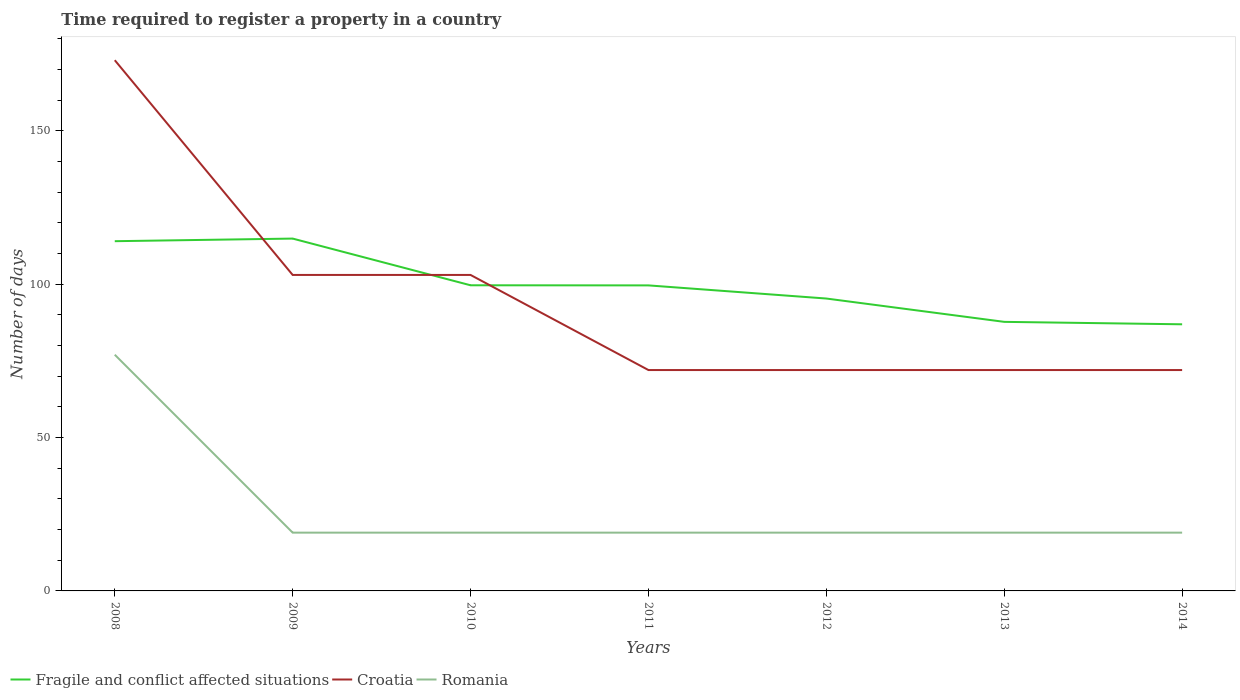How many different coloured lines are there?
Provide a short and direct response. 3. Does the line corresponding to Croatia intersect with the line corresponding to Fragile and conflict affected situations?
Your answer should be very brief. Yes. Across all years, what is the maximum number of days required to register a property in Fragile and conflict affected situations?
Provide a short and direct response. 86.91. In which year was the number of days required to register a property in Fragile and conflict affected situations maximum?
Provide a succinct answer. 2014. What is the total number of days required to register a property in Croatia in the graph?
Keep it short and to the point. 101. What is the difference between the highest and the second highest number of days required to register a property in Fragile and conflict affected situations?
Ensure brevity in your answer.  27.94. What is the difference between the highest and the lowest number of days required to register a property in Fragile and conflict affected situations?
Your answer should be very brief. 2. What is the difference between two consecutive major ticks on the Y-axis?
Your response must be concise. 50. Are the values on the major ticks of Y-axis written in scientific E-notation?
Keep it short and to the point. No. Where does the legend appear in the graph?
Provide a succinct answer. Bottom left. What is the title of the graph?
Keep it short and to the point. Time required to register a property in a country. Does "Iceland" appear as one of the legend labels in the graph?
Provide a short and direct response. No. What is the label or title of the X-axis?
Your answer should be compact. Years. What is the label or title of the Y-axis?
Provide a succinct answer. Number of days. What is the Number of days in Fragile and conflict affected situations in 2008?
Offer a terse response. 114. What is the Number of days in Croatia in 2008?
Ensure brevity in your answer.  173. What is the Number of days of Fragile and conflict affected situations in 2009?
Offer a very short reply. 114.85. What is the Number of days of Croatia in 2009?
Keep it short and to the point. 103. What is the Number of days in Fragile and conflict affected situations in 2010?
Keep it short and to the point. 99.63. What is the Number of days of Croatia in 2010?
Your answer should be very brief. 103. What is the Number of days of Romania in 2010?
Your answer should be compact. 19. What is the Number of days in Fragile and conflict affected situations in 2011?
Offer a terse response. 99.59. What is the Number of days in Romania in 2011?
Give a very brief answer. 19. What is the Number of days in Fragile and conflict affected situations in 2012?
Keep it short and to the point. 95.31. What is the Number of days of Romania in 2012?
Keep it short and to the point. 19. What is the Number of days of Fragile and conflict affected situations in 2013?
Offer a very short reply. 87.71. What is the Number of days in Fragile and conflict affected situations in 2014?
Give a very brief answer. 86.91. Across all years, what is the maximum Number of days in Fragile and conflict affected situations?
Your answer should be very brief. 114.85. Across all years, what is the maximum Number of days in Croatia?
Provide a succinct answer. 173. Across all years, what is the maximum Number of days of Romania?
Provide a short and direct response. 77. Across all years, what is the minimum Number of days of Fragile and conflict affected situations?
Offer a very short reply. 86.91. Across all years, what is the minimum Number of days in Croatia?
Make the answer very short. 72. What is the total Number of days in Fragile and conflict affected situations in the graph?
Provide a succinct answer. 698.01. What is the total Number of days in Croatia in the graph?
Your response must be concise. 667. What is the total Number of days in Romania in the graph?
Make the answer very short. 191. What is the difference between the Number of days of Fragile and conflict affected situations in 2008 and that in 2009?
Ensure brevity in your answer.  -0.85. What is the difference between the Number of days in Croatia in 2008 and that in 2009?
Your answer should be compact. 70. What is the difference between the Number of days in Romania in 2008 and that in 2009?
Your answer should be compact. 58. What is the difference between the Number of days of Fragile and conflict affected situations in 2008 and that in 2010?
Your answer should be very brief. 14.37. What is the difference between the Number of days of Fragile and conflict affected situations in 2008 and that in 2011?
Your answer should be compact. 14.41. What is the difference between the Number of days of Croatia in 2008 and that in 2011?
Offer a terse response. 101. What is the difference between the Number of days of Romania in 2008 and that in 2011?
Provide a succinct answer. 58. What is the difference between the Number of days of Fragile and conflict affected situations in 2008 and that in 2012?
Your response must be concise. 18.69. What is the difference between the Number of days of Croatia in 2008 and that in 2012?
Offer a very short reply. 101. What is the difference between the Number of days in Fragile and conflict affected situations in 2008 and that in 2013?
Make the answer very short. 26.29. What is the difference between the Number of days of Croatia in 2008 and that in 2013?
Your response must be concise. 101. What is the difference between the Number of days of Romania in 2008 and that in 2013?
Your answer should be compact. 58. What is the difference between the Number of days in Fragile and conflict affected situations in 2008 and that in 2014?
Keep it short and to the point. 27.09. What is the difference between the Number of days in Croatia in 2008 and that in 2014?
Make the answer very short. 101. What is the difference between the Number of days of Romania in 2008 and that in 2014?
Offer a terse response. 58. What is the difference between the Number of days of Fragile and conflict affected situations in 2009 and that in 2010?
Make the answer very short. 15.22. What is the difference between the Number of days of Croatia in 2009 and that in 2010?
Give a very brief answer. 0. What is the difference between the Number of days in Romania in 2009 and that in 2010?
Your response must be concise. 0. What is the difference between the Number of days of Fragile and conflict affected situations in 2009 and that in 2011?
Give a very brief answer. 15.26. What is the difference between the Number of days in Fragile and conflict affected situations in 2009 and that in 2012?
Offer a terse response. 19.54. What is the difference between the Number of days in Croatia in 2009 and that in 2012?
Give a very brief answer. 31. What is the difference between the Number of days of Romania in 2009 and that in 2012?
Your answer should be compact. 0. What is the difference between the Number of days of Fragile and conflict affected situations in 2009 and that in 2013?
Make the answer very short. 27.14. What is the difference between the Number of days of Croatia in 2009 and that in 2013?
Ensure brevity in your answer.  31. What is the difference between the Number of days of Romania in 2009 and that in 2013?
Offer a very short reply. 0. What is the difference between the Number of days in Fragile and conflict affected situations in 2009 and that in 2014?
Your response must be concise. 27.94. What is the difference between the Number of days of Fragile and conflict affected situations in 2010 and that in 2011?
Provide a short and direct response. 0.04. What is the difference between the Number of days in Croatia in 2010 and that in 2011?
Keep it short and to the point. 31. What is the difference between the Number of days in Fragile and conflict affected situations in 2010 and that in 2012?
Your response must be concise. 4.32. What is the difference between the Number of days of Croatia in 2010 and that in 2012?
Provide a succinct answer. 31. What is the difference between the Number of days of Fragile and conflict affected situations in 2010 and that in 2013?
Ensure brevity in your answer.  11.92. What is the difference between the Number of days of Fragile and conflict affected situations in 2010 and that in 2014?
Offer a very short reply. 12.72. What is the difference between the Number of days in Fragile and conflict affected situations in 2011 and that in 2012?
Offer a terse response. 4.28. What is the difference between the Number of days in Fragile and conflict affected situations in 2011 and that in 2013?
Give a very brief answer. 11.89. What is the difference between the Number of days in Croatia in 2011 and that in 2013?
Ensure brevity in your answer.  0. What is the difference between the Number of days in Fragile and conflict affected situations in 2011 and that in 2014?
Provide a succinct answer. 12.68. What is the difference between the Number of days of Croatia in 2011 and that in 2014?
Provide a short and direct response. 0. What is the difference between the Number of days in Romania in 2011 and that in 2014?
Offer a very short reply. 0. What is the difference between the Number of days in Fragile and conflict affected situations in 2012 and that in 2013?
Ensure brevity in your answer.  7.6. What is the difference between the Number of days in Romania in 2012 and that in 2013?
Give a very brief answer. 0. What is the difference between the Number of days of Fragile and conflict affected situations in 2012 and that in 2014?
Give a very brief answer. 8.4. What is the difference between the Number of days of Croatia in 2012 and that in 2014?
Your answer should be very brief. 0. What is the difference between the Number of days in Romania in 2012 and that in 2014?
Make the answer very short. 0. What is the difference between the Number of days in Fragile and conflict affected situations in 2013 and that in 2014?
Offer a terse response. 0.79. What is the difference between the Number of days in Fragile and conflict affected situations in 2008 and the Number of days in Croatia in 2009?
Offer a terse response. 11. What is the difference between the Number of days in Croatia in 2008 and the Number of days in Romania in 2009?
Offer a terse response. 154. What is the difference between the Number of days of Fragile and conflict affected situations in 2008 and the Number of days of Croatia in 2010?
Offer a very short reply. 11. What is the difference between the Number of days of Fragile and conflict affected situations in 2008 and the Number of days of Romania in 2010?
Make the answer very short. 95. What is the difference between the Number of days of Croatia in 2008 and the Number of days of Romania in 2010?
Make the answer very short. 154. What is the difference between the Number of days of Fragile and conflict affected situations in 2008 and the Number of days of Romania in 2011?
Your answer should be very brief. 95. What is the difference between the Number of days in Croatia in 2008 and the Number of days in Romania in 2011?
Offer a very short reply. 154. What is the difference between the Number of days of Fragile and conflict affected situations in 2008 and the Number of days of Croatia in 2012?
Keep it short and to the point. 42. What is the difference between the Number of days in Fragile and conflict affected situations in 2008 and the Number of days in Romania in 2012?
Give a very brief answer. 95. What is the difference between the Number of days in Croatia in 2008 and the Number of days in Romania in 2012?
Give a very brief answer. 154. What is the difference between the Number of days of Fragile and conflict affected situations in 2008 and the Number of days of Croatia in 2013?
Make the answer very short. 42. What is the difference between the Number of days of Fragile and conflict affected situations in 2008 and the Number of days of Romania in 2013?
Offer a very short reply. 95. What is the difference between the Number of days of Croatia in 2008 and the Number of days of Romania in 2013?
Ensure brevity in your answer.  154. What is the difference between the Number of days of Fragile and conflict affected situations in 2008 and the Number of days of Croatia in 2014?
Your response must be concise. 42. What is the difference between the Number of days of Fragile and conflict affected situations in 2008 and the Number of days of Romania in 2014?
Give a very brief answer. 95. What is the difference between the Number of days of Croatia in 2008 and the Number of days of Romania in 2014?
Provide a short and direct response. 154. What is the difference between the Number of days of Fragile and conflict affected situations in 2009 and the Number of days of Croatia in 2010?
Give a very brief answer. 11.85. What is the difference between the Number of days of Fragile and conflict affected situations in 2009 and the Number of days of Romania in 2010?
Keep it short and to the point. 95.85. What is the difference between the Number of days in Croatia in 2009 and the Number of days in Romania in 2010?
Provide a succinct answer. 84. What is the difference between the Number of days in Fragile and conflict affected situations in 2009 and the Number of days in Croatia in 2011?
Ensure brevity in your answer.  42.85. What is the difference between the Number of days of Fragile and conflict affected situations in 2009 and the Number of days of Romania in 2011?
Your response must be concise. 95.85. What is the difference between the Number of days in Fragile and conflict affected situations in 2009 and the Number of days in Croatia in 2012?
Your answer should be very brief. 42.85. What is the difference between the Number of days of Fragile and conflict affected situations in 2009 and the Number of days of Romania in 2012?
Your answer should be compact. 95.85. What is the difference between the Number of days in Croatia in 2009 and the Number of days in Romania in 2012?
Provide a succinct answer. 84. What is the difference between the Number of days in Fragile and conflict affected situations in 2009 and the Number of days in Croatia in 2013?
Provide a succinct answer. 42.85. What is the difference between the Number of days of Fragile and conflict affected situations in 2009 and the Number of days of Romania in 2013?
Your answer should be compact. 95.85. What is the difference between the Number of days of Croatia in 2009 and the Number of days of Romania in 2013?
Your answer should be compact. 84. What is the difference between the Number of days of Fragile and conflict affected situations in 2009 and the Number of days of Croatia in 2014?
Give a very brief answer. 42.85. What is the difference between the Number of days in Fragile and conflict affected situations in 2009 and the Number of days in Romania in 2014?
Provide a succinct answer. 95.85. What is the difference between the Number of days in Croatia in 2009 and the Number of days in Romania in 2014?
Offer a very short reply. 84. What is the difference between the Number of days in Fragile and conflict affected situations in 2010 and the Number of days in Croatia in 2011?
Ensure brevity in your answer.  27.63. What is the difference between the Number of days of Fragile and conflict affected situations in 2010 and the Number of days of Romania in 2011?
Provide a succinct answer. 80.63. What is the difference between the Number of days in Croatia in 2010 and the Number of days in Romania in 2011?
Your response must be concise. 84. What is the difference between the Number of days in Fragile and conflict affected situations in 2010 and the Number of days in Croatia in 2012?
Provide a succinct answer. 27.63. What is the difference between the Number of days in Fragile and conflict affected situations in 2010 and the Number of days in Romania in 2012?
Your response must be concise. 80.63. What is the difference between the Number of days in Fragile and conflict affected situations in 2010 and the Number of days in Croatia in 2013?
Offer a terse response. 27.63. What is the difference between the Number of days of Fragile and conflict affected situations in 2010 and the Number of days of Romania in 2013?
Offer a terse response. 80.63. What is the difference between the Number of days of Croatia in 2010 and the Number of days of Romania in 2013?
Give a very brief answer. 84. What is the difference between the Number of days in Fragile and conflict affected situations in 2010 and the Number of days in Croatia in 2014?
Keep it short and to the point. 27.63. What is the difference between the Number of days of Fragile and conflict affected situations in 2010 and the Number of days of Romania in 2014?
Your answer should be very brief. 80.63. What is the difference between the Number of days in Croatia in 2010 and the Number of days in Romania in 2014?
Provide a short and direct response. 84. What is the difference between the Number of days of Fragile and conflict affected situations in 2011 and the Number of days of Croatia in 2012?
Make the answer very short. 27.59. What is the difference between the Number of days of Fragile and conflict affected situations in 2011 and the Number of days of Romania in 2012?
Make the answer very short. 80.59. What is the difference between the Number of days of Fragile and conflict affected situations in 2011 and the Number of days of Croatia in 2013?
Keep it short and to the point. 27.59. What is the difference between the Number of days of Fragile and conflict affected situations in 2011 and the Number of days of Romania in 2013?
Give a very brief answer. 80.59. What is the difference between the Number of days in Fragile and conflict affected situations in 2011 and the Number of days in Croatia in 2014?
Provide a short and direct response. 27.59. What is the difference between the Number of days of Fragile and conflict affected situations in 2011 and the Number of days of Romania in 2014?
Offer a terse response. 80.59. What is the difference between the Number of days of Croatia in 2011 and the Number of days of Romania in 2014?
Your response must be concise. 53. What is the difference between the Number of days in Fragile and conflict affected situations in 2012 and the Number of days in Croatia in 2013?
Keep it short and to the point. 23.31. What is the difference between the Number of days of Fragile and conflict affected situations in 2012 and the Number of days of Romania in 2013?
Offer a very short reply. 76.31. What is the difference between the Number of days of Fragile and conflict affected situations in 2012 and the Number of days of Croatia in 2014?
Keep it short and to the point. 23.31. What is the difference between the Number of days in Fragile and conflict affected situations in 2012 and the Number of days in Romania in 2014?
Give a very brief answer. 76.31. What is the difference between the Number of days of Fragile and conflict affected situations in 2013 and the Number of days of Croatia in 2014?
Provide a short and direct response. 15.71. What is the difference between the Number of days of Fragile and conflict affected situations in 2013 and the Number of days of Romania in 2014?
Give a very brief answer. 68.71. What is the average Number of days of Fragile and conflict affected situations per year?
Provide a succinct answer. 99.72. What is the average Number of days of Croatia per year?
Provide a short and direct response. 95.29. What is the average Number of days in Romania per year?
Offer a terse response. 27.29. In the year 2008, what is the difference between the Number of days in Fragile and conflict affected situations and Number of days in Croatia?
Give a very brief answer. -59. In the year 2008, what is the difference between the Number of days in Croatia and Number of days in Romania?
Your answer should be compact. 96. In the year 2009, what is the difference between the Number of days in Fragile and conflict affected situations and Number of days in Croatia?
Keep it short and to the point. 11.85. In the year 2009, what is the difference between the Number of days in Fragile and conflict affected situations and Number of days in Romania?
Provide a short and direct response. 95.85. In the year 2010, what is the difference between the Number of days of Fragile and conflict affected situations and Number of days of Croatia?
Keep it short and to the point. -3.37. In the year 2010, what is the difference between the Number of days of Fragile and conflict affected situations and Number of days of Romania?
Give a very brief answer. 80.63. In the year 2010, what is the difference between the Number of days in Croatia and Number of days in Romania?
Provide a succinct answer. 84. In the year 2011, what is the difference between the Number of days in Fragile and conflict affected situations and Number of days in Croatia?
Provide a short and direct response. 27.59. In the year 2011, what is the difference between the Number of days in Fragile and conflict affected situations and Number of days in Romania?
Make the answer very short. 80.59. In the year 2012, what is the difference between the Number of days of Fragile and conflict affected situations and Number of days of Croatia?
Offer a terse response. 23.31. In the year 2012, what is the difference between the Number of days of Fragile and conflict affected situations and Number of days of Romania?
Your response must be concise. 76.31. In the year 2012, what is the difference between the Number of days of Croatia and Number of days of Romania?
Offer a very short reply. 53. In the year 2013, what is the difference between the Number of days of Fragile and conflict affected situations and Number of days of Croatia?
Your answer should be very brief. 15.71. In the year 2013, what is the difference between the Number of days in Fragile and conflict affected situations and Number of days in Romania?
Your answer should be compact. 68.71. In the year 2013, what is the difference between the Number of days of Croatia and Number of days of Romania?
Provide a short and direct response. 53. In the year 2014, what is the difference between the Number of days in Fragile and conflict affected situations and Number of days in Croatia?
Offer a terse response. 14.91. In the year 2014, what is the difference between the Number of days in Fragile and conflict affected situations and Number of days in Romania?
Offer a terse response. 67.91. In the year 2014, what is the difference between the Number of days in Croatia and Number of days in Romania?
Your answer should be compact. 53. What is the ratio of the Number of days in Fragile and conflict affected situations in 2008 to that in 2009?
Offer a terse response. 0.99. What is the ratio of the Number of days of Croatia in 2008 to that in 2009?
Provide a succinct answer. 1.68. What is the ratio of the Number of days of Romania in 2008 to that in 2009?
Provide a short and direct response. 4.05. What is the ratio of the Number of days of Fragile and conflict affected situations in 2008 to that in 2010?
Your answer should be compact. 1.14. What is the ratio of the Number of days of Croatia in 2008 to that in 2010?
Your response must be concise. 1.68. What is the ratio of the Number of days of Romania in 2008 to that in 2010?
Offer a terse response. 4.05. What is the ratio of the Number of days in Fragile and conflict affected situations in 2008 to that in 2011?
Offer a terse response. 1.14. What is the ratio of the Number of days in Croatia in 2008 to that in 2011?
Your answer should be compact. 2.4. What is the ratio of the Number of days in Romania in 2008 to that in 2011?
Give a very brief answer. 4.05. What is the ratio of the Number of days of Fragile and conflict affected situations in 2008 to that in 2012?
Provide a succinct answer. 1.2. What is the ratio of the Number of days of Croatia in 2008 to that in 2012?
Provide a succinct answer. 2.4. What is the ratio of the Number of days of Romania in 2008 to that in 2012?
Provide a succinct answer. 4.05. What is the ratio of the Number of days of Fragile and conflict affected situations in 2008 to that in 2013?
Keep it short and to the point. 1.3. What is the ratio of the Number of days of Croatia in 2008 to that in 2013?
Make the answer very short. 2.4. What is the ratio of the Number of days of Romania in 2008 to that in 2013?
Keep it short and to the point. 4.05. What is the ratio of the Number of days of Fragile and conflict affected situations in 2008 to that in 2014?
Your response must be concise. 1.31. What is the ratio of the Number of days of Croatia in 2008 to that in 2014?
Make the answer very short. 2.4. What is the ratio of the Number of days in Romania in 2008 to that in 2014?
Your answer should be compact. 4.05. What is the ratio of the Number of days in Fragile and conflict affected situations in 2009 to that in 2010?
Offer a terse response. 1.15. What is the ratio of the Number of days of Romania in 2009 to that in 2010?
Your response must be concise. 1. What is the ratio of the Number of days in Fragile and conflict affected situations in 2009 to that in 2011?
Provide a short and direct response. 1.15. What is the ratio of the Number of days in Croatia in 2009 to that in 2011?
Keep it short and to the point. 1.43. What is the ratio of the Number of days in Romania in 2009 to that in 2011?
Offer a terse response. 1. What is the ratio of the Number of days of Fragile and conflict affected situations in 2009 to that in 2012?
Your answer should be compact. 1.21. What is the ratio of the Number of days of Croatia in 2009 to that in 2012?
Your response must be concise. 1.43. What is the ratio of the Number of days in Romania in 2009 to that in 2012?
Provide a short and direct response. 1. What is the ratio of the Number of days in Fragile and conflict affected situations in 2009 to that in 2013?
Offer a very short reply. 1.31. What is the ratio of the Number of days of Croatia in 2009 to that in 2013?
Provide a short and direct response. 1.43. What is the ratio of the Number of days of Fragile and conflict affected situations in 2009 to that in 2014?
Offer a very short reply. 1.32. What is the ratio of the Number of days in Croatia in 2009 to that in 2014?
Your response must be concise. 1.43. What is the ratio of the Number of days in Croatia in 2010 to that in 2011?
Provide a succinct answer. 1.43. What is the ratio of the Number of days in Romania in 2010 to that in 2011?
Ensure brevity in your answer.  1. What is the ratio of the Number of days in Fragile and conflict affected situations in 2010 to that in 2012?
Make the answer very short. 1.05. What is the ratio of the Number of days in Croatia in 2010 to that in 2012?
Ensure brevity in your answer.  1.43. What is the ratio of the Number of days of Fragile and conflict affected situations in 2010 to that in 2013?
Your answer should be compact. 1.14. What is the ratio of the Number of days of Croatia in 2010 to that in 2013?
Ensure brevity in your answer.  1.43. What is the ratio of the Number of days of Fragile and conflict affected situations in 2010 to that in 2014?
Make the answer very short. 1.15. What is the ratio of the Number of days in Croatia in 2010 to that in 2014?
Offer a very short reply. 1.43. What is the ratio of the Number of days of Romania in 2010 to that in 2014?
Give a very brief answer. 1. What is the ratio of the Number of days of Fragile and conflict affected situations in 2011 to that in 2012?
Keep it short and to the point. 1.04. What is the ratio of the Number of days in Fragile and conflict affected situations in 2011 to that in 2013?
Your answer should be compact. 1.14. What is the ratio of the Number of days of Croatia in 2011 to that in 2013?
Your answer should be compact. 1. What is the ratio of the Number of days of Fragile and conflict affected situations in 2011 to that in 2014?
Your answer should be very brief. 1.15. What is the ratio of the Number of days in Romania in 2011 to that in 2014?
Your answer should be very brief. 1. What is the ratio of the Number of days of Fragile and conflict affected situations in 2012 to that in 2013?
Make the answer very short. 1.09. What is the ratio of the Number of days in Croatia in 2012 to that in 2013?
Offer a very short reply. 1. What is the ratio of the Number of days in Fragile and conflict affected situations in 2012 to that in 2014?
Give a very brief answer. 1.1. What is the ratio of the Number of days of Croatia in 2012 to that in 2014?
Ensure brevity in your answer.  1. What is the ratio of the Number of days in Romania in 2012 to that in 2014?
Provide a short and direct response. 1. What is the ratio of the Number of days in Fragile and conflict affected situations in 2013 to that in 2014?
Give a very brief answer. 1.01. What is the ratio of the Number of days in Romania in 2013 to that in 2014?
Your response must be concise. 1. What is the difference between the highest and the second highest Number of days of Fragile and conflict affected situations?
Your response must be concise. 0.85. What is the difference between the highest and the lowest Number of days in Fragile and conflict affected situations?
Make the answer very short. 27.94. What is the difference between the highest and the lowest Number of days of Croatia?
Offer a very short reply. 101. What is the difference between the highest and the lowest Number of days in Romania?
Your answer should be very brief. 58. 